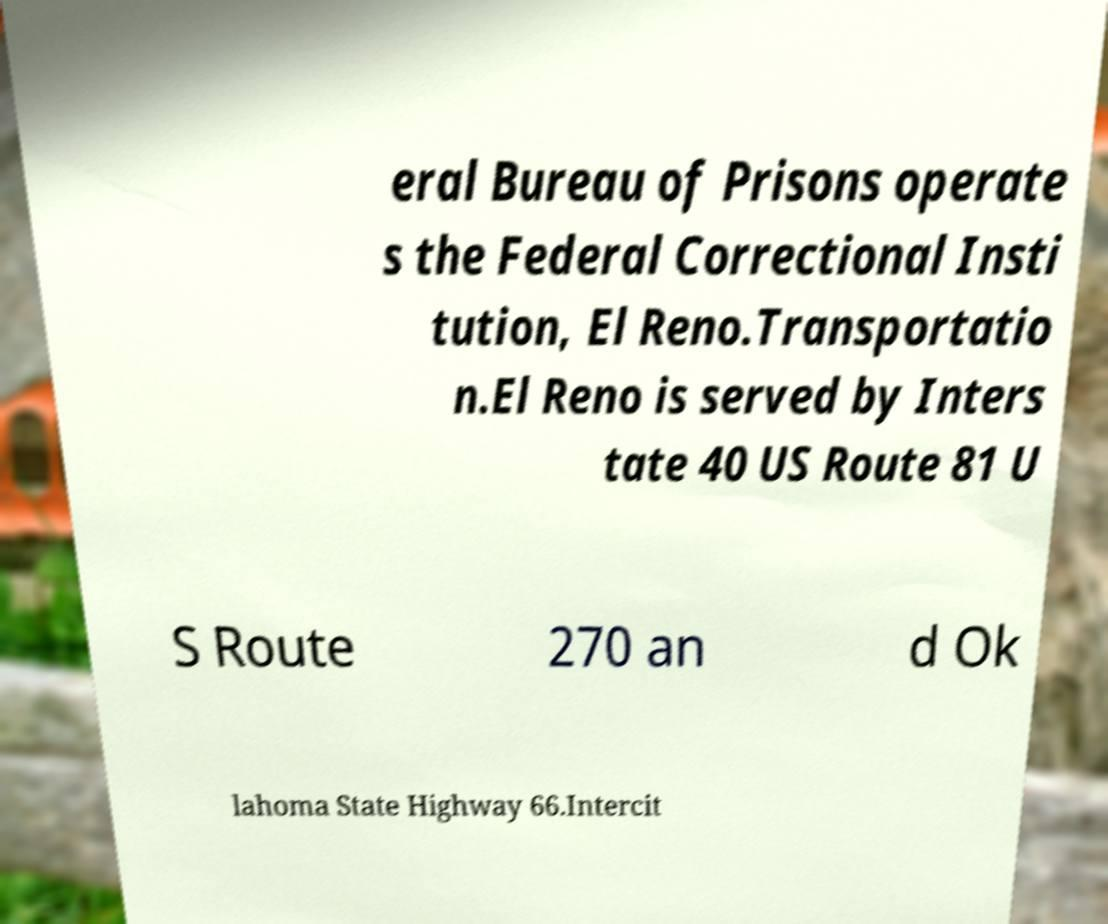Please identify and transcribe the text found in this image. eral Bureau of Prisons operate s the Federal Correctional Insti tution, El Reno.Transportatio n.El Reno is served by Inters tate 40 US Route 81 U S Route 270 an d Ok lahoma State Highway 66.Intercit 